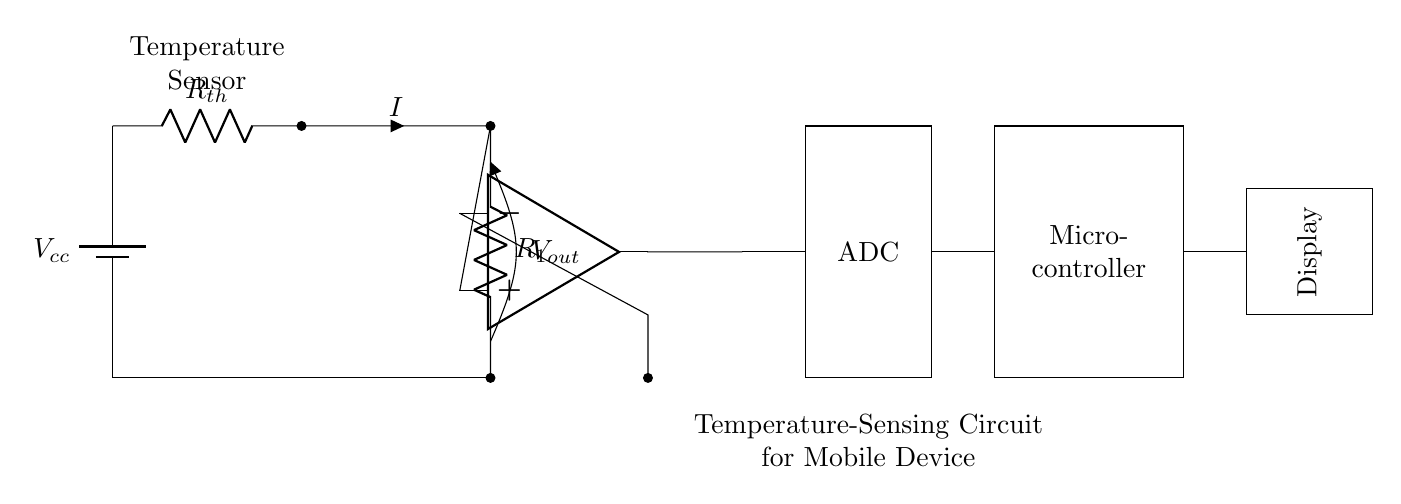What component is used to sense temperature? The component used to sense temperature is a thermistor, which is represented as R_th in the circuit diagram.
Answer: thermistor What is the output voltage labeled in the circuit? The output voltage from the voltage divider is labeled as V_out in the circuit diagram, shown at the junction of the fixed resistor and thermistor.
Answer: V_out How many main components are there in this circuit? The main components include a thermistor, a fixed resistor, an operational amplifier, an ADC, a microcontroller, and a display. Therefore, there are six main components total.
Answer: six What does the ADC do in this circuit? The ADC converts the analog voltage from the operational amplifier into a digital signal that the microcontroller can process. This conversion is crucial for digital data handling.
Answer: converts analog to digital What is the role of the microcontroller in this circuit? The microcontroller processes the data from the ADC and manages the information flow to the display, allowing it to present the temperature information visually.
Answer: data processing Which components form a voltage divider? The thermistor and the fixed resistor form a voltage divider, where the output voltage is taken across the fixed resistor connected to the ground.
Answer: thermistor and fixed resistor What feature does the display provide in the mobile device? The display provides a visual output of the temperature readings, allowing users to easily monitor the device's heat levels during usage.
Answer: visual output 